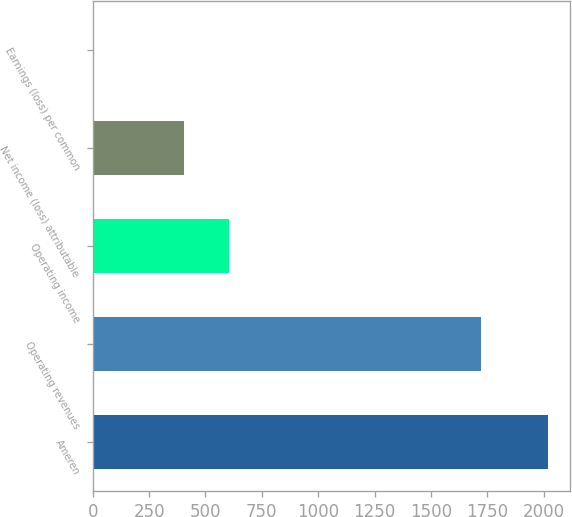<chart> <loc_0><loc_0><loc_500><loc_500><bar_chart><fcel>Ameren<fcel>Operating revenues<fcel>Operating income<fcel>Net income (loss) attributable<fcel>Earnings (loss) per common<nl><fcel>2017<fcel>1723<fcel>605.92<fcel>404.34<fcel>1.18<nl></chart> 